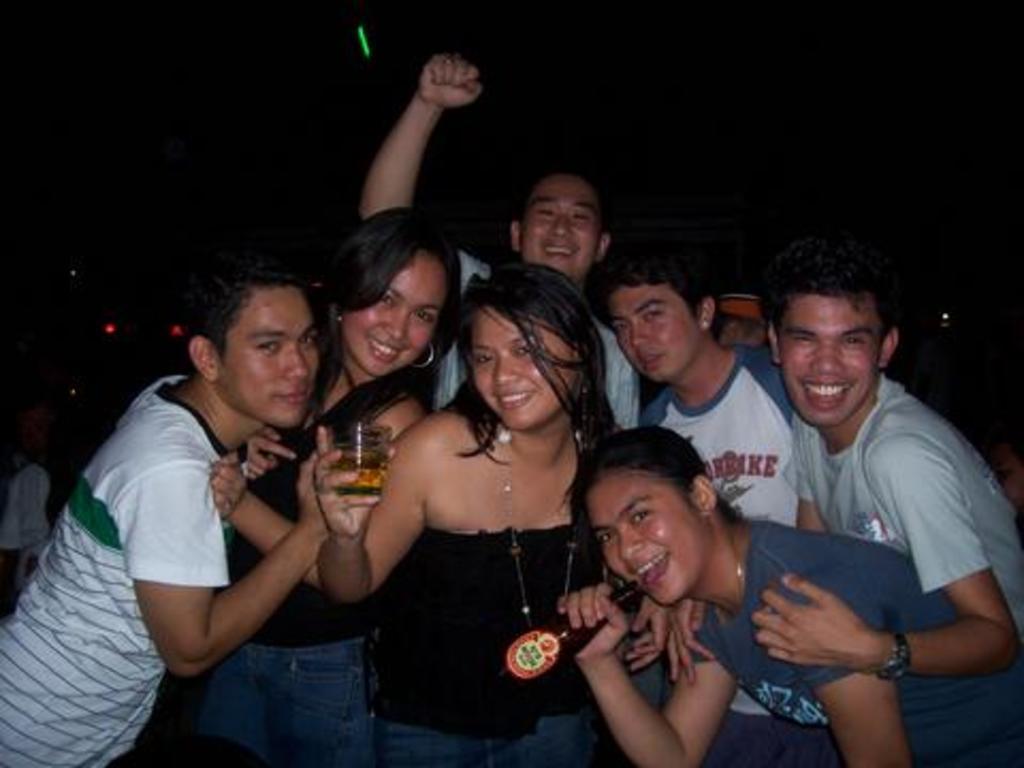Describe this image in one or two sentences. In this image we can see a group of people standing. In that a woman is holding a glass with beer and the other is holding a bottle. 